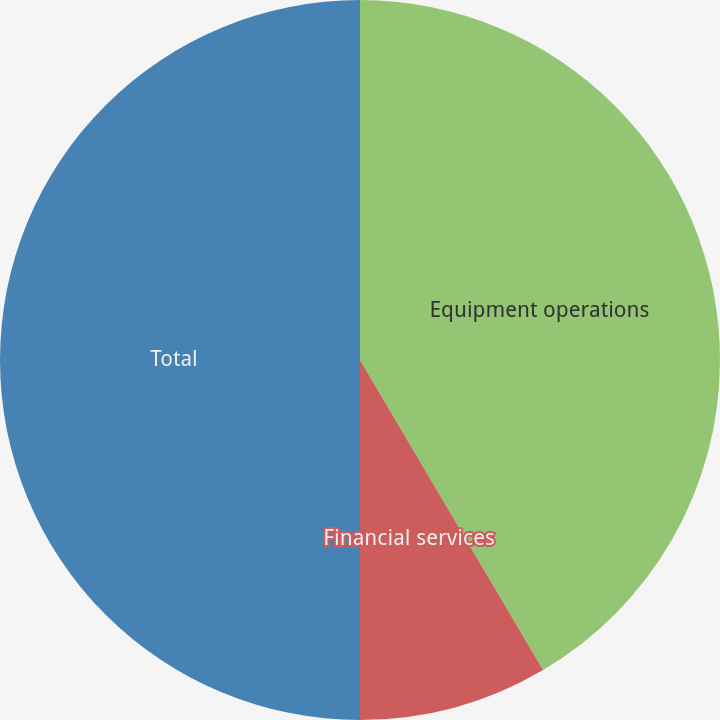Convert chart. <chart><loc_0><loc_0><loc_500><loc_500><pie_chart><fcel>Equipment operations<fcel>Financial services<fcel>Total<nl><fcel>41.51%<fcel>8.49%<fcel>50.0%<nl></chart> 